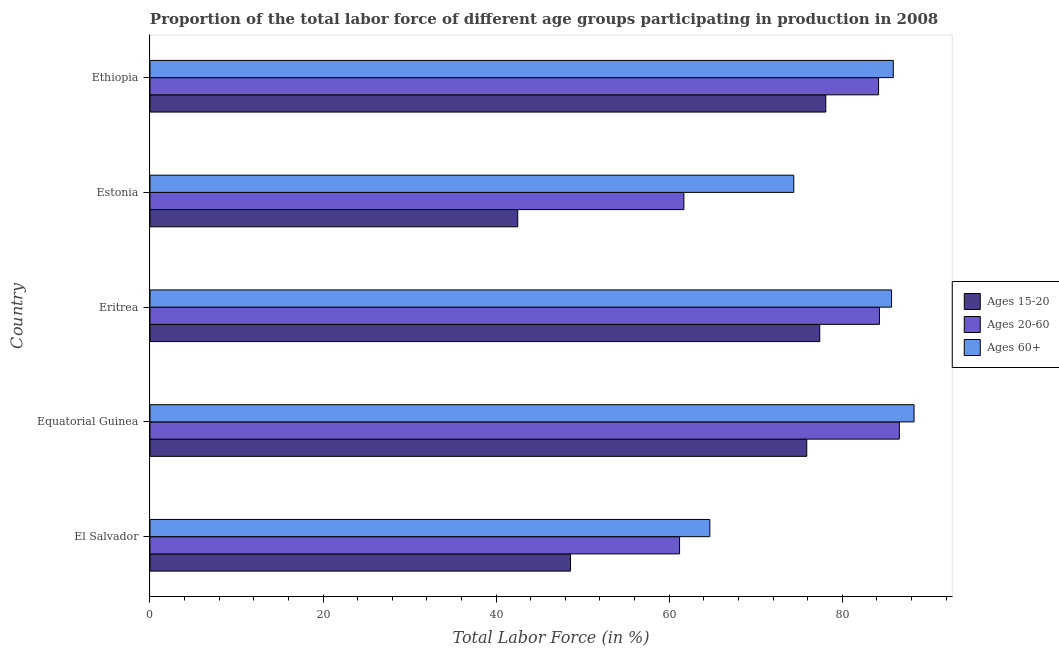How many different coloured bars are there?
Give a very brief answer. 3. Are the number of bars on each tick of the Y-axis equal?
Your answer should be compact. Yes. How many bars are there on the 3rd tick from the top?
Offer a terse response. 3. How many bars are there on the 5th tick from the bottom?
Offer a very short reply. 3. What is the label of the 5th group of bars from the top?
Your answer should be compact. El Salvador. What is the percentage of labor force within the age group 15-20 in Equatorial Guinea?
Your answer should be compact. 75.9. Across all countries, what is the maximum percentage of labor force within the age group 20-60?
Ensure brevity in your answer.  86.6. Across all countries, what is the minimum percentage of labor force above age 60?
Offer a very short reply. 64.7. In which country was the percentage of labor force above age 60 maximum?
Offer a very short reply. Equatorial Guinea. In which country was the percentage of labor force within the age group 20-60 minimum?
Offer a terse response. El Salvador. What is the total percentage of labor force within the age group 20-60 in the graph?
Your answer should be very brief. 378. What is the difference between the percentage of labor force within the age group 20-60 in Eritrea and that in Estonia?
Your answer should be compact. 22.6. What is the difference between the percentage of labor force above age 60 in Eritrea and the percentage of labor force within the age group 15-20 in Estonia?
Provide a short and direct response. 43.2. What is the average percentage of labor force above age 60 per country?
Provide a succinct answer. 79.8. What is the difference between the percentage of labor force within the age group 15-20 and percentage of labor force within the age group 20-60 in Equatorial Guinea?
Your answer should be very brief. -10.7. In how many countries, is the percentage of labor force above age 60 greater than 72 %?
Provide a succinct answer. 4. What is the ratio of the percentage of labor force within the age group 15-20 in Eritrea to that in Estonia?
Ensure brevity in your answer.  1.82. What is the difference between the highest and the lowest percentage of labor force within the age group 15-20?
Provide a short and direct response. 35.6. In how many countries, is the percentage of labor force above age 60 greater than the average percentage of labor force above age 60 taken over all countries?
Your answer should be very brief. 3. Is the sum of the percentage of labor force within the age group 15-20 in Eritrea and Estonia greater than the maximum percentage of labor force above age 60 across all countries?
Give a very brief answer. Yes. What does the 3rd bar from the top in Ethiopia represents?
Your answer should be very brief. Ages 15-20. What does the 3rd bar from the bottom in Eritrea represents?
Keep it short and to the point. Ages 60+. Is it the case that in every country, the sum of the percentage of labor force within the age group 15-20 and percentage of labor force within the age group 20-60 is greater than the percentage of labor force above age 60?
Your response must be concise. Yes. How many bars are there?
Offer a very short reply. 15. How many countries are there in the graph?
Keep it short and to the point. 5. Does the graph contain grids?
Provide a short and direct response. No. How many legend labels are there?
Your answer should be very brief. 3. How are the legend labels stacked?
Keep it short and to the point. Vertical. What is the title of the graph?
Your response must be concise. Proportion of the total labor force of different age groups participating in production in 2008. Does "Coal" appear as one of the legend labels in the graph?
Offer a very short reply. No. What is the label or title of the Y-axis?
Keep it short and to the point. Country. What is the Total Labor Force (in %) in Ages 15-20 in El Salvador?
Offer a terse response. 48.6. What is the Total Labor Force (in %) of Ages 20-60 in El Salvador?
Your response must be concise. 61.2. What is the Total Labor Force (in %) in Ages 60+ in El Salvador?
Your answer should be very brief. 64.7. What is the Total Labor Force (in %) of Ages 15-20 in Equatorial Guinea?
Give a very brief answer. 75.9. What is the Total Labor Force (in %) of Ages 20-60 in Equatorial Guinea?
Your response must be concise. 86.6. What is the Total Labor Force (in %) in Ages 60+ in Equatorial Guinea?
Your answer should be compact. 88.3. What is the Total Labor Force (in %) of Ages 15-20 in Eritrea?
Provide a short and direct response. 77.4. What is the Total Labor Force (in %) of Ages 20-60 in Eritrea?
Provide a short and direct response. 84.3. What is the Total Labor Force (in %) in Ages 60+ in Eritrea?
Offer a terse response. 85.7. What is the Total Labor Force (in %) of Ages 15-20 in Estonia?
Offer a terse response. 42.5. What is the Total Labor Force (in %) in Ages 20-60 in Estonia?
Offer a terse response. 61.7. What is the Total Labor Force (in %) of Ages 60+ in Estonia?
Keep it short and to the point. 74.4. What is the Total Labor Force (in %) in Ages 15-20 in Ethiopia?
Give a very brief answer. 78.1. What is the Total Labor Force (in %) of Ages 20-60 in Ethiopia?
Your response must be concise. 84.2. What is the Total Labor Force (in %) of Ages 60+ in Ethiopia?
Ensure brevity in your answer.  85.9. Across all countries, what is the maximum Total Labor Force (in %) of Ages 15-20?
Ensure brevity in your answer.  78.1. Across all countries, what is the maximum Total Labor Force (in %) of Ages 20-60?
Make the answer very short. 86.6. Across all countries, what is the maximum Total Labor Force (in %) in Ages 60+?
Provide a short and direct response. 88.3. Across all countries, what is the minimum Total Labor Force (in %) in Ages 15-20?
Give a very brief answer. 42.5. Across all countries, what is the minimum Total Labor Force (in %) of Ages 20-60?
Give a very brief answer. 61.2. Across all countries, what is the minimum Total Labor Force (in %) of Ages 60+?
Ensure brevity in your answer.  64.7. What is the total Total Labor Force (in %) in Ages 15-20 in the graph?
Your response must be concise. 322.5. What is the total Total Labor Force (in %) of Ages 20-60 in the graph?
Provide a short and direct response. 378. What is the total Total Labor Force (in %) of Ages 60+ in the graph?
Offer a very short reply. 399. What is the difference between the Total Labor Force (in %) in Ages 15-20 in El Salvador and that in Equatorial Guinea?
Your answer should be very brief. -27.3. What is the difference between the Total Labor Force (in %) in Ages 20-60 in El Salvador and that in Equatorial Guinea?
Give a very brief answer. -25.4. What is the difference between the Total Labor Force (in %) in Ages 60+ in El Salvador and that in Equatorial Guinea?
Your response must be concise. -23.6. What is the difference between the Total Labor Force (in %) in Ages 15-20 in El Salvador and that in Eritrea?
Provide a succinct answer. -28.8. What is the difference between the Total Labor Force (in %) of Ages 20-60 in El Salvador and that in Eritrea?
Provide a succinct answer. -23.1. What is the difference between the Total Labor Force (in %) in Ages 60+ in El Salvador and that in Eritrea?
Offer a very short reply. -21. What is the difference between the Total Labor Force (in %) of Ages 15-20 in El Salvador and that in Estonia?
Your answer should be compact. 6.1. What is the difference between the Total Labor Force (in %) in Ages 60+ in El Salvador and that in Estonia?
Make the answer very short. -9.7. What is the difference between the Total Labor Force (in %) in Ages 15-20 in El Salvador and that in Ethiopia?
Provide a short and direct response. -29.5. What is the difference between the Total Labor Force (in %) of Ages 60+ in El Salvador and that in Ethiopia?
Offer a very short reply. -21.2. What is the difference between the Total Labor Force (in %) in Ages 15-20 in Equatorial Guinea and that in Eritrea?
Provide a short and direct response. -1.5. What is the difference between the Total Labor Force (in %) in Ages 15-20 in Equatorial Guinea and that in Estonia?
Offer a terse response. 33.4. What is the difference between the Total Labor Force (in %) in Ages 20-60 in Equatorial Guinea and that in Estonia?
Your answer should be compact. 24.9. What is the difference between the Total Labor Force (in %) in Ages 60+ in Equatorial Guinea and that in Estonia?
Offer a terse response. 13.9. What is the difference between the Total Labor Force (in %) in Ages 15-20 in Equatorial Guinea and that in Ethiopia?
Provide a succinct answer. -2.2. What is the difference between the Total Labor Force (in %) in Ages 60+ in Equatorial Guinea and that in Ethiopia?
Ensure brevity in your answer.  2.4. What is the difference between the Total Labor Force (in %) in Ages 15-20 in Eritrea and that in Estonia?
Keep it short and to the point. 34.9. What is the difference between the Total Labor Force (in %) in Ages 20-60 in Eritrea and that in Estonia?
Keep it short and to the point. 22.6. What is the difference between the Total Labor Force (in %) in Ages 15-20 in Eritrea and that in Ethiopia?
Make the answer very short. -0.7. What is the difference between the Total Labor Force (in %) in Ages 20-60 in Eritrea and that in Ethiopia?
Provide a succinct answer. 0.1. What is the difference between the Total Labor Force (in %) in Ages 60+ in Eritrea and that in Ethiopia?
Ensure brevity in your answer.  -0.2. What is the difference between the Total Labor Force (in %) of Ages 15-20 in Estonia and that in Ethiopia?
Give a very brief answer. -35.6. What is the difference between the Total Labor Force (in %) in Ages 20-60 in Estonia and that in Ethiopia?
Offer a terse response. -22.5. What is the difference between the Total Labor Force (in %) in Ages 60+ in Estonia and that in Ethiopia?
Keep it short and to the point. -11.5. What is the difference between the Total Labor Force (in %) of Ages 15-20 in El Salvador and the Total Labor Force (in %) of Ages 20-60 in Equatorial Guinea?
Make the answer very short. -38. What is the difference between the Total Labor Force (in %) of Ages 15-20 in El Salvador and the Total Labor Force (in %) of Ages 60+ in Equatorial Guinea?
Offer a terse response. -39.7. What is the difference between the Total Labor Force (in %) in Ages 20-60 in El Salvador and the Total Labor Force (in %) in Ages 60+ in Equatorial Guinea?
Make the answer very short. -27.1. What is the difference between the Total Labor Force (in %) in Ages 15-20 in El Salvador and the Total Labor Force (in %) in Ages 20-60 in Eritrea?
Provide a short and direct response. -35.7. What is the difference between the Total Labor Force (in %) of Ages 15-20 in El Salvador and the Total Labor Force (in %) of Ages 60+ in Eritrea?
Provide a succinct answer. -37.1. What is the difference between the Total Labor Force (in %) of Ages 20-60 in El Salvador and the Total Labor Force (in %) of Ages 60+ in Eritrea?
Your answer should be compact. -24.5. What is the difference between the Total Labor Force (in %) in Ages 15-20 in El Salvador and the Total Labor Force (in %) in Ages 20-60 in Estonia?
Your answer should be compact. -13.1. What is the difference between the Total Labor Force (in %) of Ages 15-20 in El Salvador and the Total Labor Force (in %) of Ages 60+ in Estonia?
Provide a succinct answer. -25.8. What is the difference between the Total Labor Force (in %) in Ages 15-20 in El Salvador and the Total Labor Force (in %) in Ages 20-60 in Ethiopia?
Offer a very short reply. -35.6. What is the difference between the Total Labor Force (in %) in Ages 15-20 in El Salvador and the Total Labor Force (in %) in Ages 60+ in Ethiopia?
Your response must be concise. -37.3. What is the difference between the Total Labor Force (in %) in Ages 20-60 in El Salvador and the Total Labor Force (in %) in Ages 60+ in Ethiopia?
Keep it short and to the point. -24.7. What is the difference between the Total Labor Force (in %) in Ages 15-20 in Equatorial Guinea and the Total Labor Force (in %) in Ages 20-60 in Eritrea?
Give a very brief answer. -8.4. What is the difference between the Total Labor Force (in %) in Ages 15-20 in Equatorial Guinea and the Total Labor Force (in %) in Ages 60+ in Eritrea?
Your answer should be compact. -9.8. What is the difference between the Total Labor Force (in %) of Ages 20-60 in Equatorial Guinea and the Total Labor Force (in %) of Ages 60+ in Eritrea?
Make the answer very short. 0.9. What is the difference between the Total Labor Force (in %) in Ages 15-20 in Equatorial Guinea and the Total Labor Force (in %) in Ages 60+ in Estonia?
Give a very brief answer. 1.5. What is the difference between the Total Labor Force (in %) in Ages 20-60 in Equatorial Guinea and the Total Labor Force (in %) in Ages 60+ in Estonia?
Keep it short and to the point. 12.2. What is the difference between the Total Labor Force (in %) of Ages 15-20 in Equatorial Guinea and the Total Labor Force (in %) of Ages 20-60 in Ethiopia?
Provide a short and direct response. -8.3. What is the difference between the Total Labor Force (in %) in Ages 15-20 in Equatorial Guinea and the Total Labor Force (in %) in Ages 60+ in Ethiopia?
Make the answer very short. -10. What is the difference between the Total Labor Force (in %) in Ages 20-60 in Equatorial Guinea and the Total Labor Force (in %) in Ages 60+ in Ethiopia?
Your answer should be compact. 0.7. What is the difference between the Total Labor Force (in %) of Ages 15-20 in Eritrea and the Total Labor Force (in %) of Ages 20-60 in Estonia?
Ensure brevity in your answer.  15.7. What is the difference between the Total Labor Force (in %) of Ages 20-60 in Eritrea and the Total Labor Force (in %) of Ages 60+ in Estonia?
Your answer should be very brief. 9.9. What is the difference between the Total Labor Force (in %) in Ages 15-20 in Estonia and the Total Labor Force (in %) in Ages 20-60 in Ethiopia?
Provide a succinct answer. -41.7. What is the difference between the Total Labor Force (in %) of Ages 15-20 in Estonia and the Total Labor Force (in %) of Ages 60+ in Ethiopia?
Ensure brevity in your answer.  -43.4. What is the difference between the Total Labor Force (in %) of Ages 20-60 in Estonia and the Total Labor Force (in %) of Ages 60+ in Ethiopia?
Your answer should be very brief. -24.2. What is the average Total Labor Force (in %) in Ages 15-20 per country?
Ensure brevity in your answer.  64.5. What is the average Total Labor Force (in %) in Ages 20-60 per country?
Provide a succinct answer. 75.6. What is the average Total Labor Force (in %) of Ages 60+ per country?
Make the answer very short. 79.8. What is the difference between the Total Labor Force (in %) in Ages 15-20 and Total Labor Force (in %) in Ages 20-60 in El Salvador?
Offer a very short reply. -12.6. What is the difference between the Total Labor Force (in %) in Ages 15-20 and Total Labor Force (in %) in Ages 60+ in El Salvador?
Offer a terse response. -16.1. What is the difference between the Total Labor Force (in %) of Ages 15-20 and Total Labor Force (in %) of Ages 20-60 in Equatorial Guinea?
Make the answer very short. -10.7. What is the difference between the Total Labor Force (in %) of Ages 15-20 and Total Labor Force (in %) of Ages 60+ in Equatorial Guinea?
Your response must be concise. -12.4. What is the difference between the Total Labor Force (in %) in Ages 15-20 and Total Labor Force (in %) in Ages 20-60 in Eritrea?
Give a very brief answer. -6.9. What is the difference between the Total Labor Force (in %) of Ages 20-60 and Total Labor Force (in %) of Ages 60+ in Eritrea?
Provide a short and direct response. -1.4. What is the difference between the Total Labor Force (in %) in Ages 15-20 and Total Labor Force (in %) in Ages 20-60 in Estonia?
Keep it short and to the point. -19.2. What is the difference between the Total Labor Force (in %) of Ages 15-20 and Total Labor Force (in %) of Ages 60+ in Estonia?
Provide a succinct answer. -31.9. What is the difference between the Total Labor Force (in %) of Ages 15-20 and Total Labor Force (in %) of Ages 20-60 in Ethiopia?
Offer a very short reply. -6.1. What is the ratio of the Total Labor Force (in %) of Ages 15-20 in El Salvador to that in Equatorial Guinea?
Ensure brevity in your answer.  0.64. What is the ratio of the Total Labor Force (in %) in Ages 20-60 in El Salvador to that in Equatorial Guinea?
Offer a very short reply. 0.71. What is the ratio of the Total Labor Force (in %) in Ages 60+ in El Salvador to that in Equatorial Guinea?
Ensure brevity in your answer.  0.73. What is the ratio of the Total Labor Force (in %) in Ages 15-20 in El Salvador to that in Eritrea?
Your response must be concise. 0.63. What is the ratio of the Total Labor Force (in %) of Ages 20-60 in El Salvador to that in Eritrea?
Offer a terse response. 0.73. What is the ratio of the Total Labor Force (in %) of Ages 60+ in El Salvador to that in Eritrea?
Your answer should be compact. 0.76. What is the ratio of the Total Labor Force (in %) in Ages 15-20 in El Salvador to that in Estonia?
Give a very brief answer. 1.14. What is the ratio of the Total Labor Force (in %) of Ages 60+ in El Salvador to that in Estonia?
Your answer should be compact. 0.87. What is the ratio of the Total Labor Force (in %) of Ages 15-20 in El Salvador to that in Ethiopia?
Make the answer very short. 0.62. What is the ratio of the Total Labor Force (in %) of Ages 20-60 in El Salvador to that in Ethiopia?
Offer a very short reply. 0.73. What is the ratio of the Total Labor Force (in %) of Ages 60+ in El Salvador to that in Ethiopia?
Provide a succinct answer. 0.75. What is the ratio of the Total Labor Force (in %) in Ages 15-20 in Equatorial Guinea to that in Eritrea?
Offer a very short reply. 0.98. What is the ratio of the Total Labor Force (in %) of Ages 20-60 in Equatorial Guinea to that in Eritrea?
Your response must be concise. 1.03. What is the ratio of the Total Labor Force (in %) in Ages 60+ in Equatorial Guinea to that in Eritrea?
Offer a very short reply. 1.03. What is the ratio of the Total Labor Force (in %) in Ages 15-20 in Equatorial Guinea to that in Estonia?
Your answer should be compact. 1.79. What is the ratio of the Total Labor Force (in %) of Ages 20-60 in Equatorial Guinea to that in Estonia?
Make the answer very short. 1.4. What is the ratio of the Total Labor Force (in %) in Ages 60+ in Equatorial Guinea to that in Estonia?
Make the answer very short. 1.19. What is the ratio of the Total Labor Force (in %) in Ages 15-20 in Equatorial Guinea to that in Ethiopia?
Your answer should be compact. 0.97. What is the ratio of the Total Labor Force (in %) of Ages 20-60 in Equatorial Guinea to that in Ethiopia?
Your response must be concise. 1.03. What is the ratio of the Total Labor Force (in %) of Ages 60+ in Equatorial Guinea to that in Ethiopia?
Provide a succinct answer. 1.03. What is the ratio of the Total Labor Force (in %) of Ages 15-20 in Eritrea to that in Estonia?
Ensure brevity in your answer.  1.82. What is the ratio of the Total Labor Force (in %) in Ages 20-60 in Eritrea to that in Estonia?
Provide a short and direct response. 1.37. What is the ratio of the Total Labor Force (in %) of Ages 60+ in Eritrea to that in Estonia?
Keep it short and to the point. 1.15. What is the ratio of the Total Labor Force (in %) of Ages 15-20 in Eritrea to that in Ethiopia?
Your answer should be very brief. 0.99. What is the ratio of the Total Labor Force (in %) of Ages 20-60 in Eritrea to that in Ethiopia?
Provide a short and direct response. 1. What is the ratio of the Total Labor Force (in %) in Ages 60+ in Eritrea to that in Ethiopia?
Your answer should be compact. 1. What is the ratio of the Total Labor Force (in %) of Ages 15-20 in Estonia to that in Ethiopia?
Provide a short and direct response. 0.54. What is the ratio of the Total Labor Force (in %) in Ages 20-60 in Estonia to that in Ethiopia?
Offer a terse response. 0.73. What is the ratio of the Total Labor Force (in %) of Ages 60+ in Estonia to that in Ethiopia?
Make the answer very short. 0.87. What is the difference between the highest and the second highest Total Labor Force (in %) of Ages 60+?
Give a very brief answer. 2.4. What is the difference between the highest and the lowest Total Labor Force (in %) of Ages 15-20?
Your response must be concise. 35.6. What is the difference between the highest and the lowest Total Labor Force (in %) in Ages 20-60?
Offer a very short reply. 25.4. What is the difference between the highest and the lowest Total Labor Force (in %) of Ages 60+?
Your response must be concise. 23.6. 